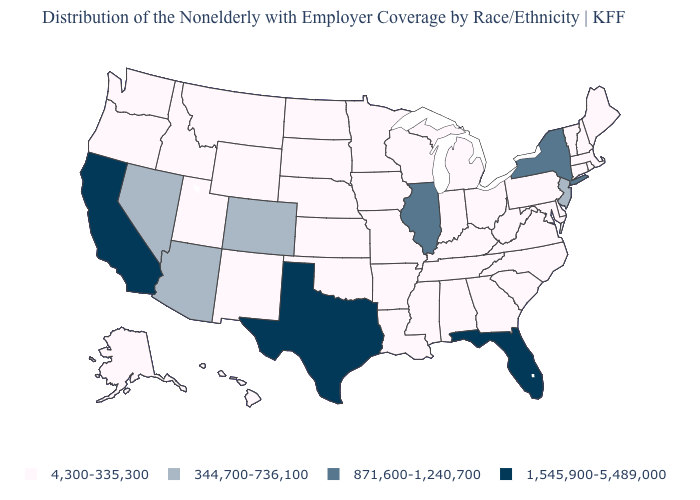What is the value of Kentucky?
Quick response, please. 4,300-335,300. Name the states that have a value in the range 4,300-335,300?
Quick response, please. Alabama, Alaska, Arkansas, Connecticut, Delaware, Georgia, Hawaii, Idaho, Indiana, Iowa, Kansas, Kentucky, Louisiana, Maine, Maryland, Massachusetts, Michigan, Minnesota, Mississippi, Missouri, Montana, Nebraska, New Hampshire, New Mexico, North Carolina, North Dakota, Ohio, Oklahoma, Oregon, Pennsylvania, Rhode Island, South Carolina, South Dakota, Tennessee, Utah, Vermont, Virginia, Washington, West Virginia, Wisconsin, Wyoming. Among the states that border Rhode Island , which have the lowest value?
Be succinct. Connecticut, Massachusetts. What is the value of Iowa?
Answer briefly. 4,300-335,300. Does Arizona have a higher value than Oklahoma?
Keep it brief. Yes. Is the legend a continuous bar?
Concise answer only. No. What is the highest value in the West ?
Give a very brief answer. 1,545,900-5,489,000. Is the legend a continuous bar?
Short answer required. No. Name the states that have a value in the range 1,545,900-5,489,000?
Keep it brief. California, Florida, Texas. Does Kansas have the highest value in the USA?
Quick response, please. No. Among the states that border Wisconsin , does Illinois have the highest value?
Concise answer only. Yes. Name the states that have a value in the range 871,600-1,240,700?
Write a very short answer. Illinois, New York. What is the highest value in the South ?
Quick response, please. 1,545,900-5,489,000. Name the states that have a value in the range 1,545,900-5,489,000?
Write a very short answer. California, Florida, Texas. What is the value of Michigan?
Concise answer only. 4,300-335,300. 